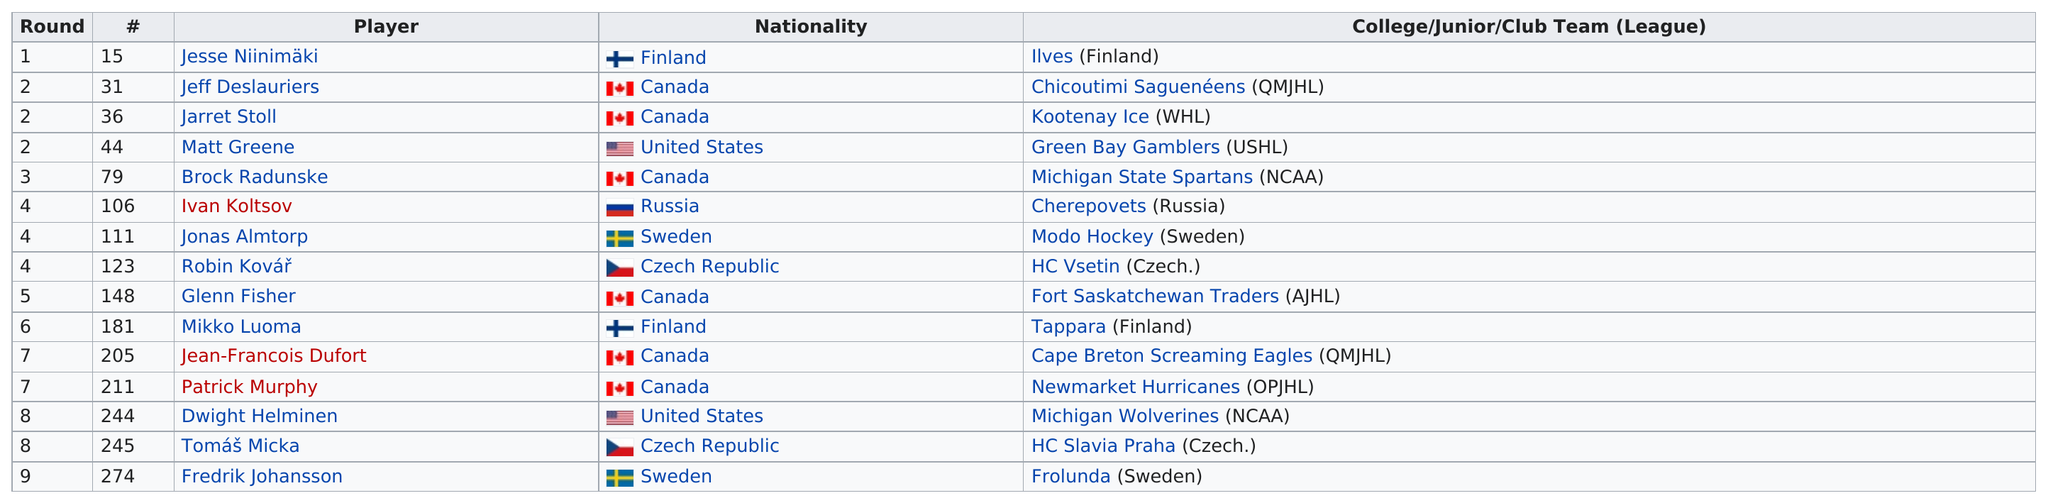Point out several critical features in this image. With the ninth pick in the draft, the team selected Fredrik Johansson, who was the only player to be selected in that round. Canada is the nationality that is most heavily represented on this chart. According to the NCAA, two players have their league listed as the NCAA. Canada has the most players of any nationality in this field. It is clear that Russia has the least number of players compared to other nationalities in the sport. 